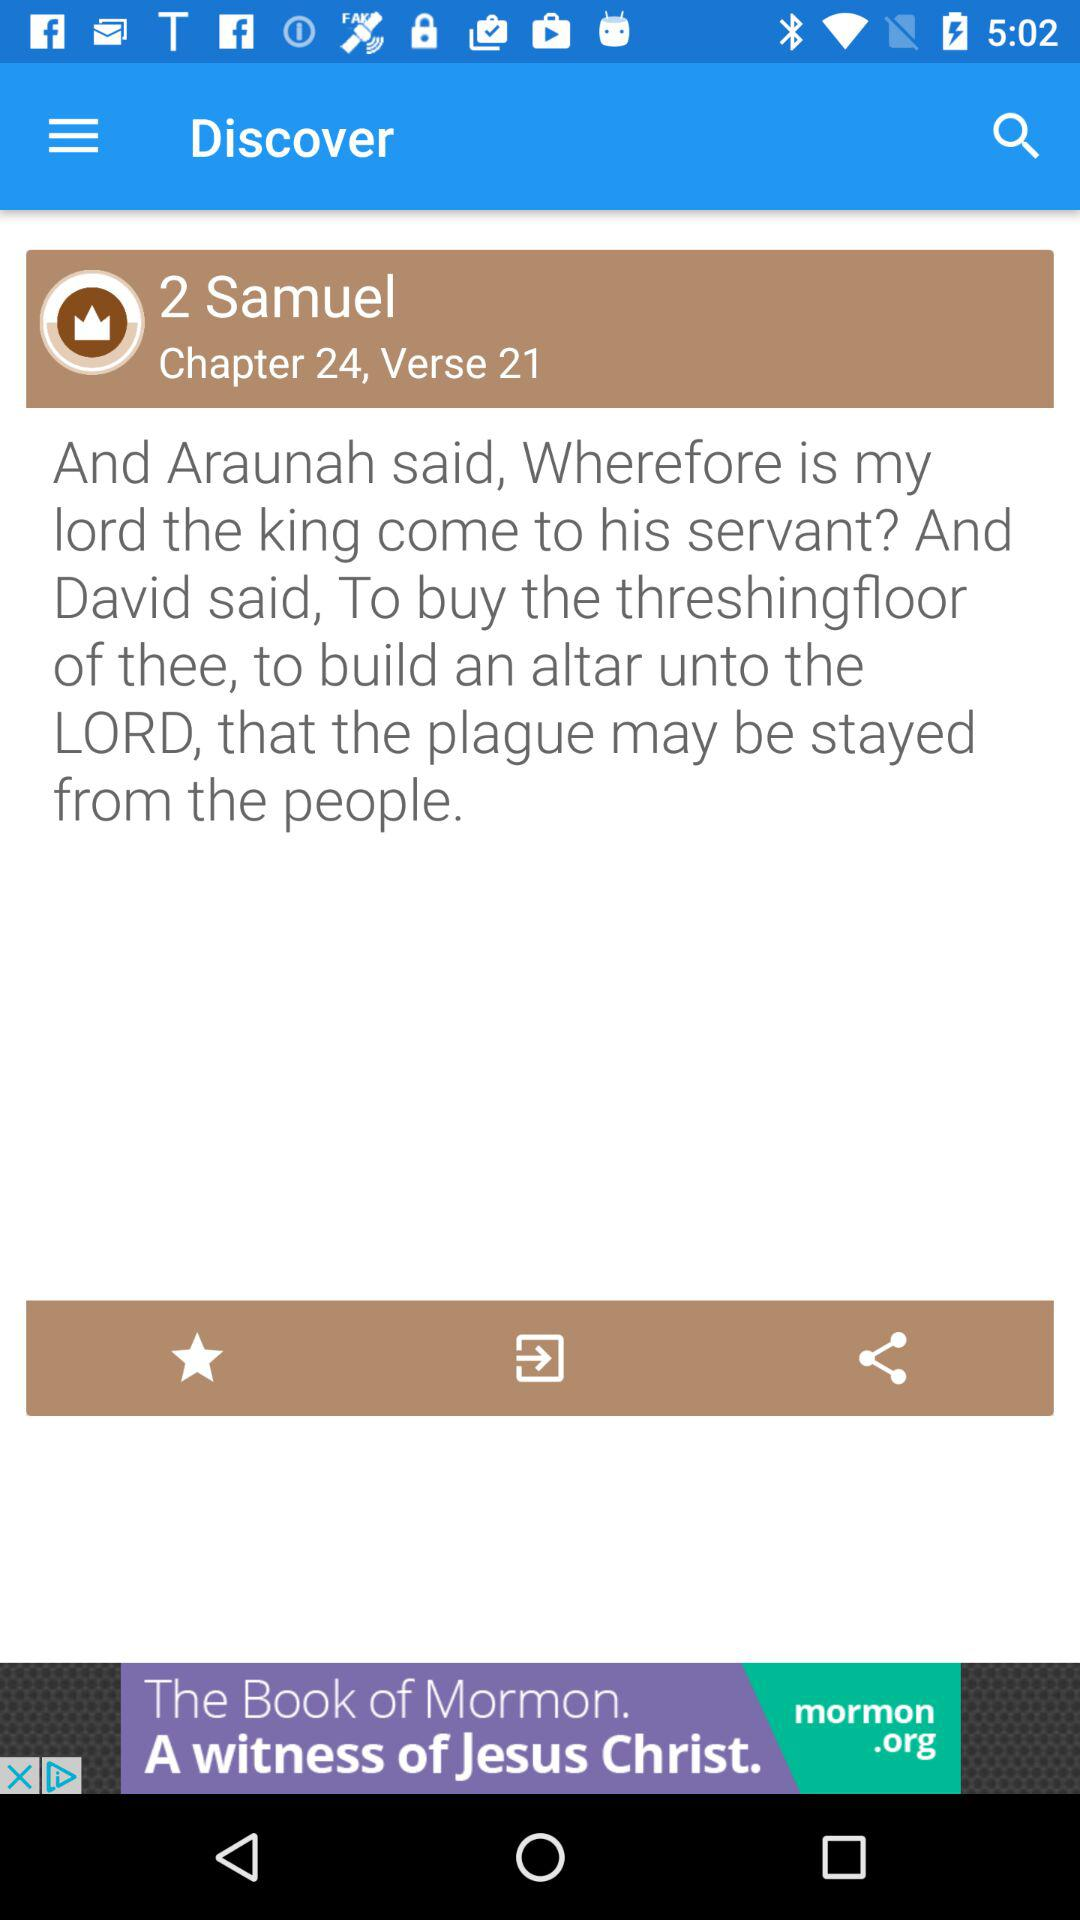What is the verse number? The verse number is 21. 